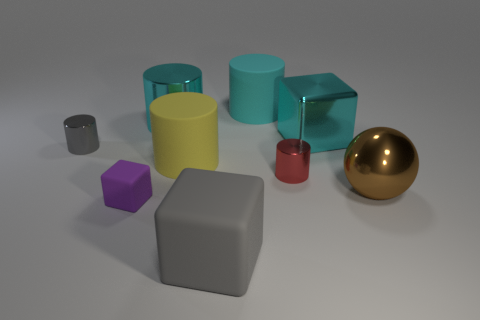What number of things are either rubber things that are on the right side of the large gray rubber block or cyan rubber spheres?
Ensure brevity in your answer.  1. What number of things are small yellow metal cylinders or tiny metallic cylinders that are behind the small red shiny cylinder?
Give a very brief answer. 1. What number of brown objects have the same size as the yellow rubber cylinder?
Make the answer very short. 1. Are there fewer gray things that are to the right of the purple rubber thing than red metal cylinders behind the large cyan cube?
Your answer should be very brief. No. How many rubber things are either small green balls or objects?
Offer a terse response. 4. There is a small red object; what shape is it?
Provide a short and direct response. Cylinder. What is the material of the red cylinder that is the same size as the purple matte cube?
Offer a very short reply. Metal. How many small objects are either yellow cylinders or cyan metal cylinders?
Make the answer very short. 0. Is there a tiny brown thing?
Provide a succinct answer. No. There is a yellow cylinder that is made of the same material as the small purple cube; what size is it?
Your answer should be very brief. Large. 